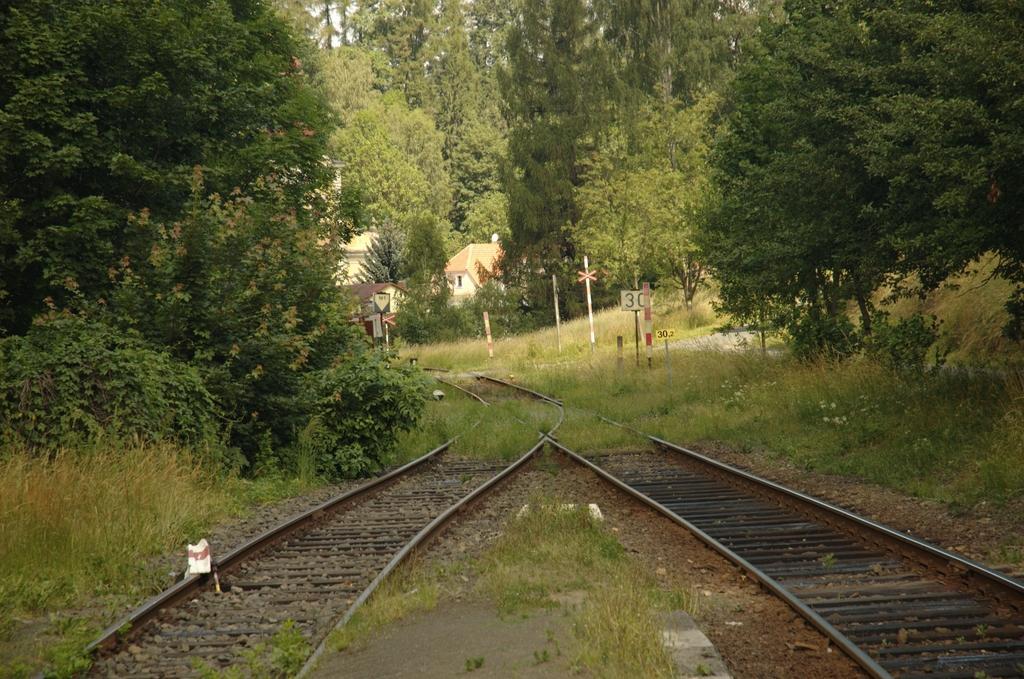In one or two sentences, can you explain what this image depicts? In this picture I can observe two railway tracks. On either sides of the tracks I can observe grass, plants and trees. In the background I can observe houses. 